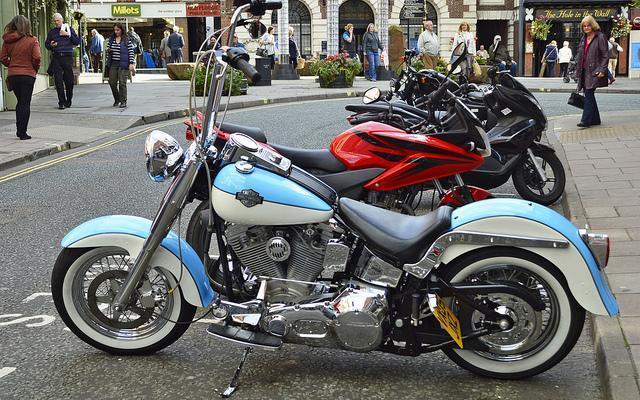How many motorcycles are there?
Give a very brief answer. 4. How many motorcycles are visible?
Give a very brief answer. 4. How many people can be seen?
Give a very brief answer. 4. 